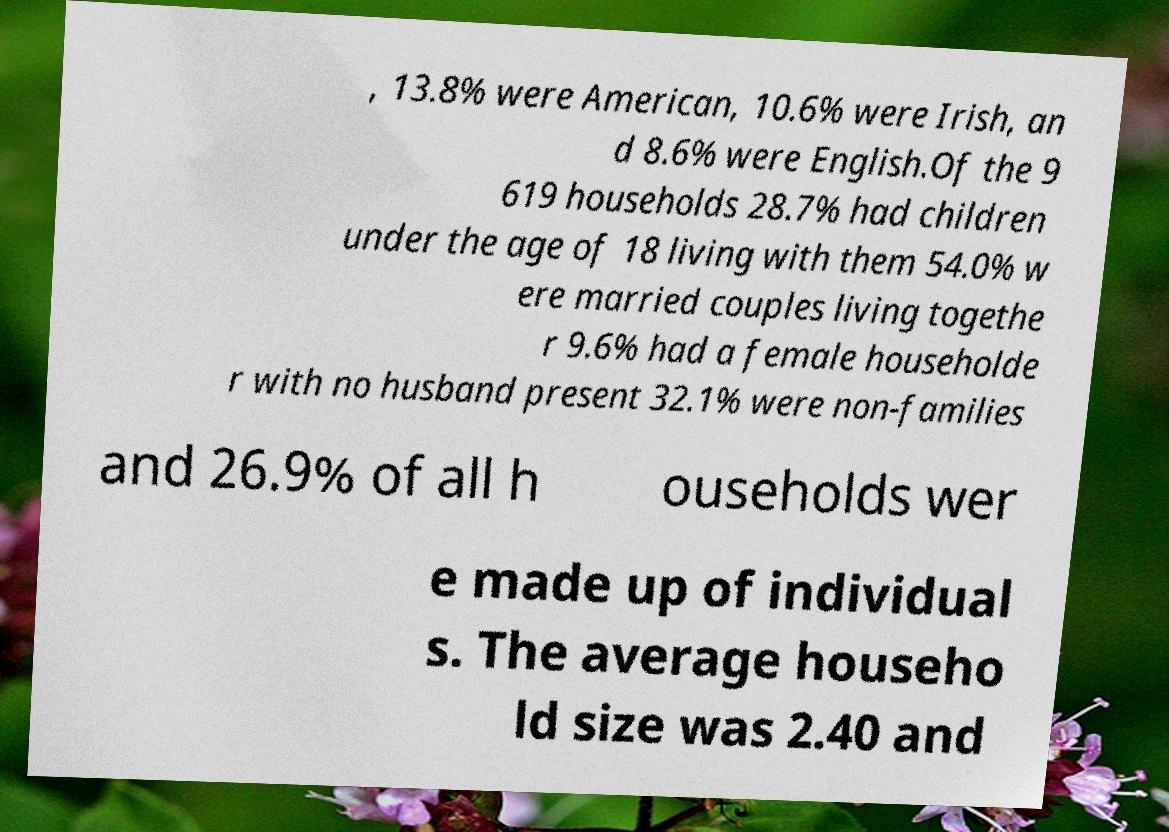For documentation purposes, I need the text within this image transcribed. Could you provide that? , 13.8% were American, 10.6% were Irish, an d 8.6% were English.Of the 9 619 households 28.7% had children under the age of 18 living with them 54.0% w ere married couples living togethe r 9.6% had a female householde r with no husband present 32.1% were non-families and 26.9% of all h ouseholds wer e made up of individual s. The average househo ld size was 2.40 and 